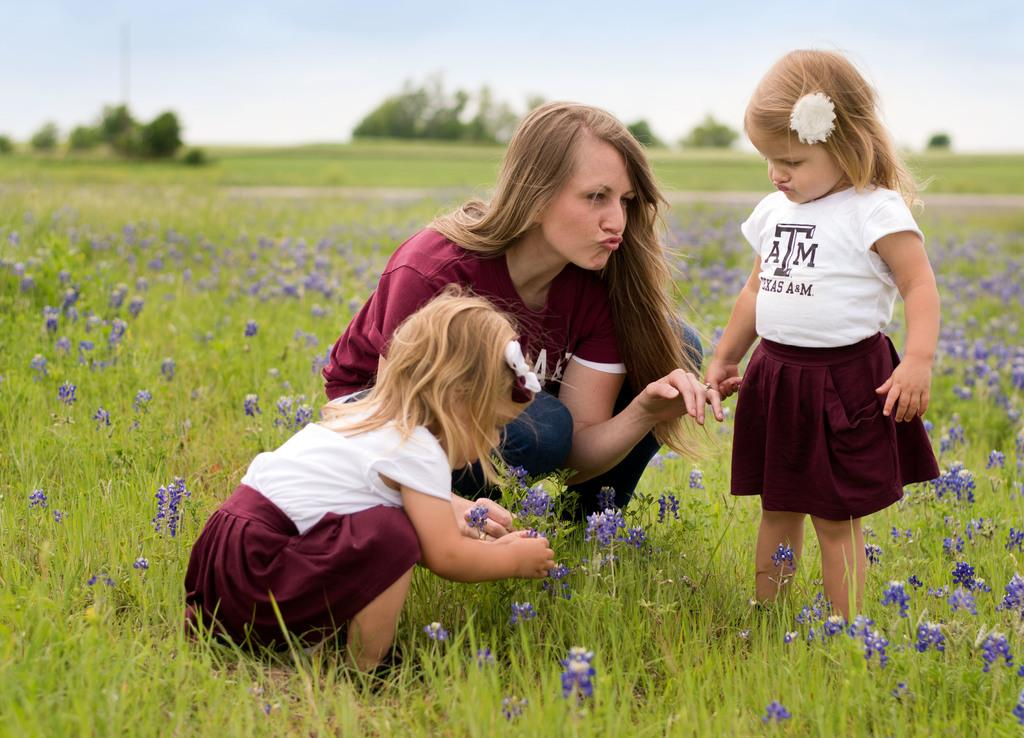How many people are in the image? There are three persons in the image. Can you describe the gender of one of the persons? One of the persons is a woman. What is the age group of the other two persons? The other two persons are kids. Where are the persons standing in the image? The persons are standing on a grass field. What can be seen in the background of the image? There is a group of trees and the sky visible in the background of the image. What type of trade is being conducted between the kids and the woman in the image? There is no indication of any trade being conducted in the image; the persons are simply standing on a grass field. How many basketballs can be seen in the image? There are no basketballs present in the image. 